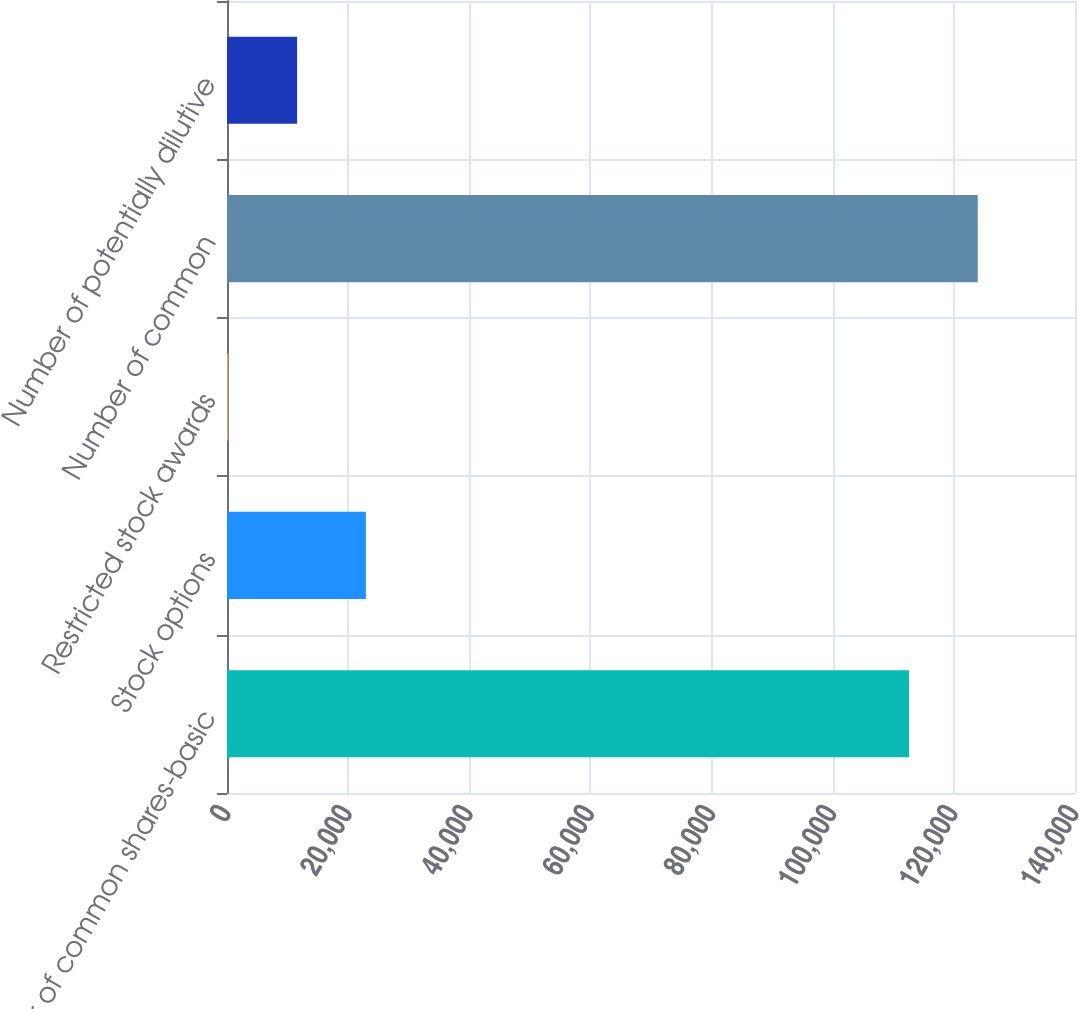<chart> <loc_0><loc_0><loc_500><loc_500><bar_chart><fcel>Number of common shares-basic<fcel>Stock options<fcel>Restricted stock awards<fcel>Number of common<fcel>Number of potentially dilutive<nl><fcel>112593<fcel>22927<fcel>224<fcel>123944<fcel>11575.5<nl></chart> 